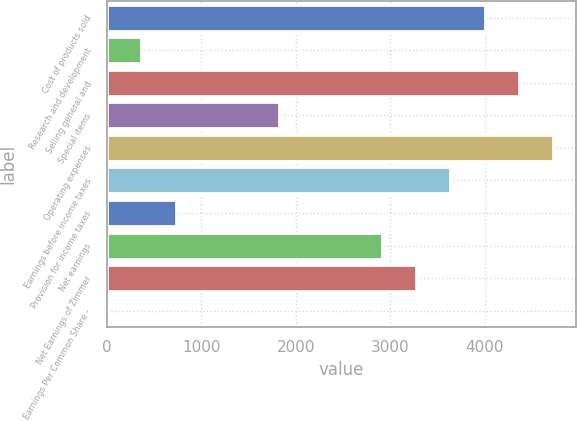Convert chart to OTSL. <chart><loc_0><loc_0><loc_500><loc_500><bar_chart><fcel>Cost of products sold<fcel>Research and development<fcel>Selling general and<fcel>Special items<fcel>Operating expenses<fcel>Earnings before income taxes<fcel>Provision for income taxes<fcel>Net earnings<fcel>Net Earnings of Zimmer<fcel>Earnings Per Common Share -<nl><fcel>3999.18<fcel>367.38<fcel>4362.36<fcel>1820.1<fcel>4725.54<fcel>3636<fcel>730.56<fcel>2909.64<fcel>3272.82<fcel>4.2<nl></chart> 